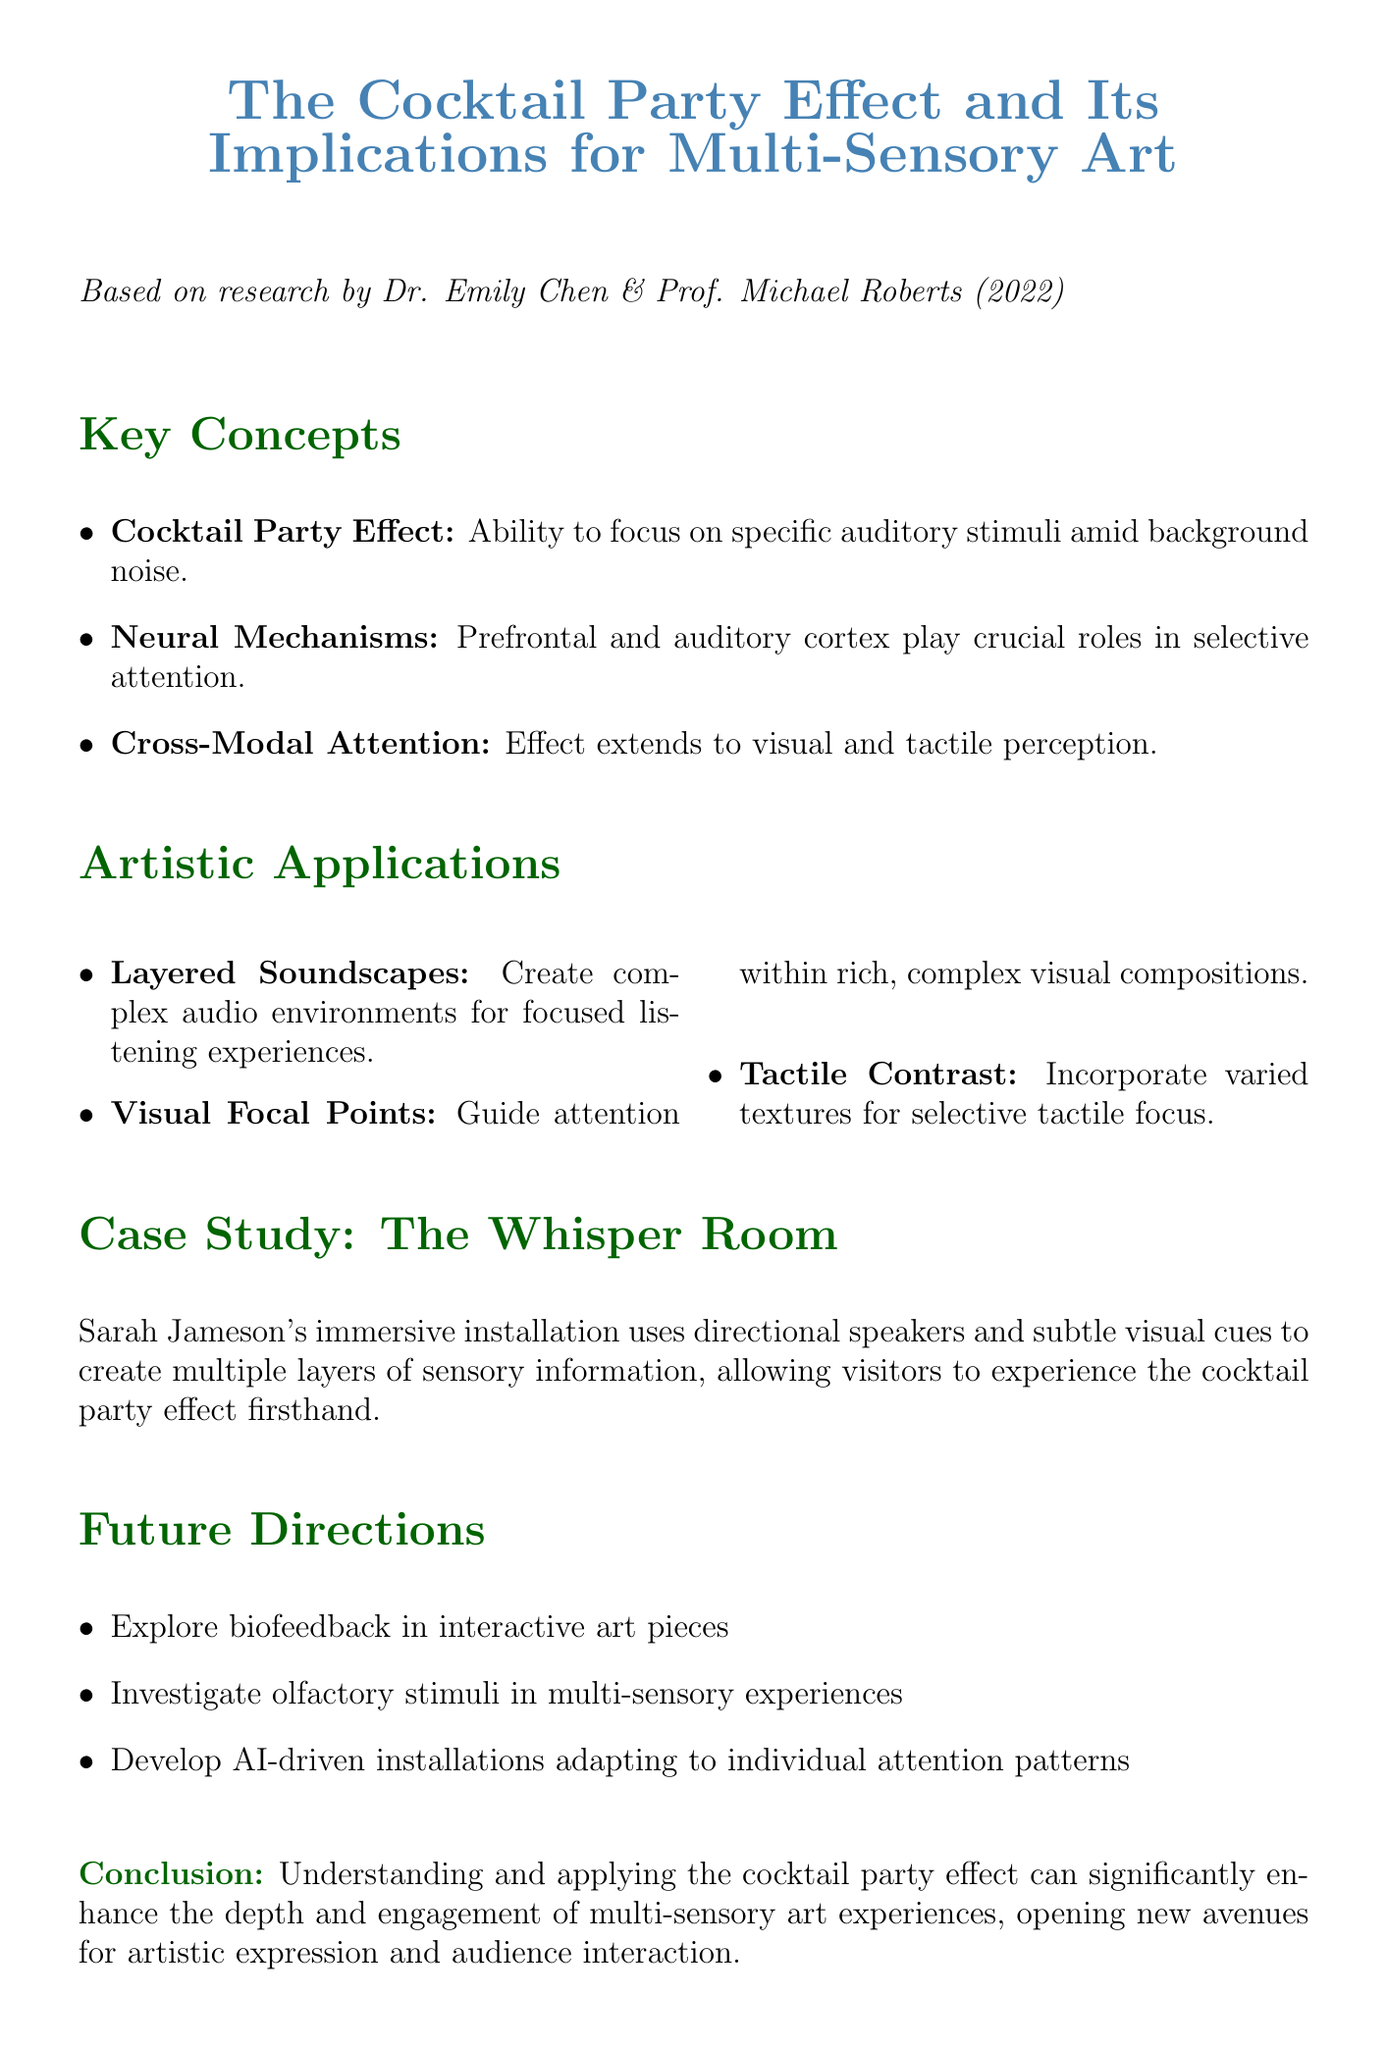What is the title of the research paper? The title of the research paper is stated in the document as "Selective Attention and the Cocktail Party Effect: Implications for Immersive Art Installations."
Answer: Selective Attention and the Cocktail Party Effect: Implications for Immersive Art Installations Who are the authors of the research paper? The authors of the research paper are listed in the document as Dr. Emily Chen and Prof. Michael Roberts.
Answer: Dr. Emily Chen, Prof. Michael Roberts What year was the research paper published? The document mentions that the research paper was published in 2022.
Answer: 2022 What is one technique for creating multi-sensory art? The document suggests "Layered Soundscapes" as one technique for creating complex audio environments.
Answer: Layered Soundscapes What role do the prefrontal and auditory cortices play? According to the document, the prefrontal cortex and auditory cortex play crucial roles in selective attention during the cocktail party effect.
Answer: Selective attention How does the cocktail party effect extend beyond auditory stimuli? The document notes that the cocktail party effect influences visual and tactile perception as well, indicating cross-modal attention.
Answer: Visual and tactile perception What is the name of the case study installation? The document refers to the case study installation as "The Whisper Room."
Answer: The Whisper Room What might artists explore in future directions? The document mentions the exploration of biofeedback to enhance selective attention in interactive art pieces as a future direction.
Answer: Biofeedback What conclusion is drawn regarding the cocktail party effect in art? The conclusion states that understanding the cocktail party effect can enhance the depth and engagement of multi-sensory art experiences.
Answer: Enhance the depth and engagement 